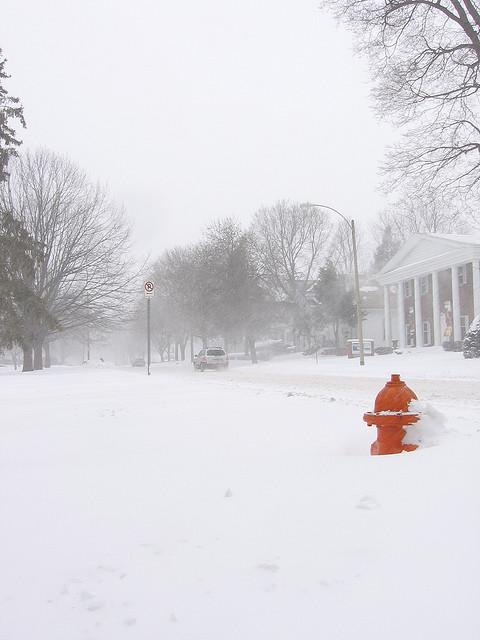What season was this photo likely taken in?
Concise answer only. Winter. What color is the fire hydrant?
Quick response, please. Red. How many pillars are on the building?
Be succinct. 6. 